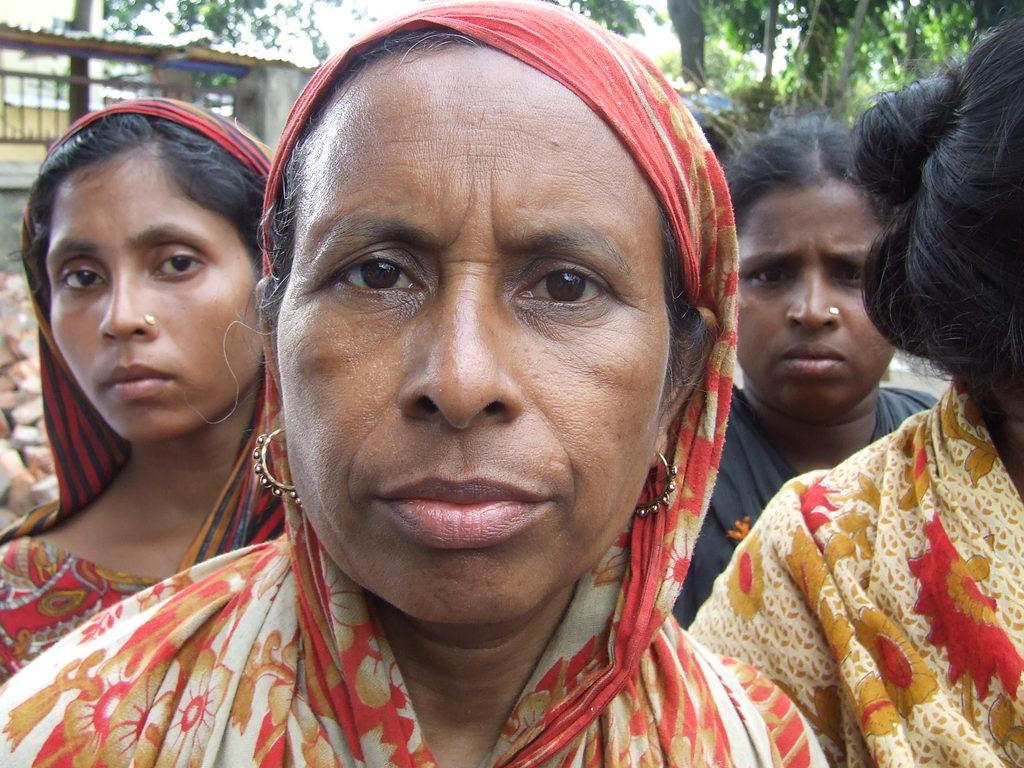What is the main subject in the center of the image? There are persons in the center of the image. What can be seen in the background of the image? There is a shed, a wall, rocks, and trees in the background of the image. What is visible at the top of the image? The sky is visible at the top of the image. How many chickens are present in the bedroom in the image? There is no bedroom or chickens present in the image. 